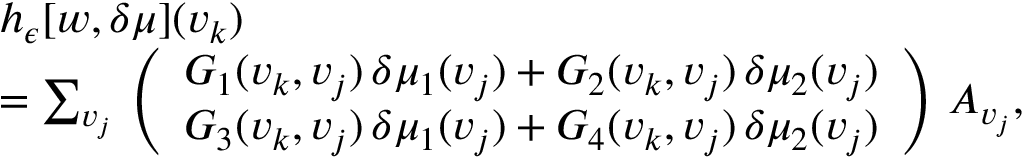<formula> <loc_0><loc_0><loc_500><loc_500>\begin{array} { r l } & { h _ { \epsilon } [ w , \delta \mu ] ( v _ { k } ) } \\ & { = \sum _ { v _ { j } } \, \left ( \begin{array} { l } { G _ { 1 } ( v _ { k } , v _ { j } ) \, \delta \mu _ { 1 } ( v _ { j } ) + G _ { 2 } ( v _ { k } , v _ { j } ) \, \delta \mu _ { 2 } ( v _ { j } ) } \\ { G _ { 3 } ( v _ { k } , v _ { j } ) \, \delta \mu _ { 1 } ( v _ { j } ) + G _ { 4 } ( v _ { k } , v _ { j } ) \, \delta \mu _ { 2 } ( v _ { j } ) } \end{array} \right ) \, A _ { v _ { j } } , } \end{array}</formula> 